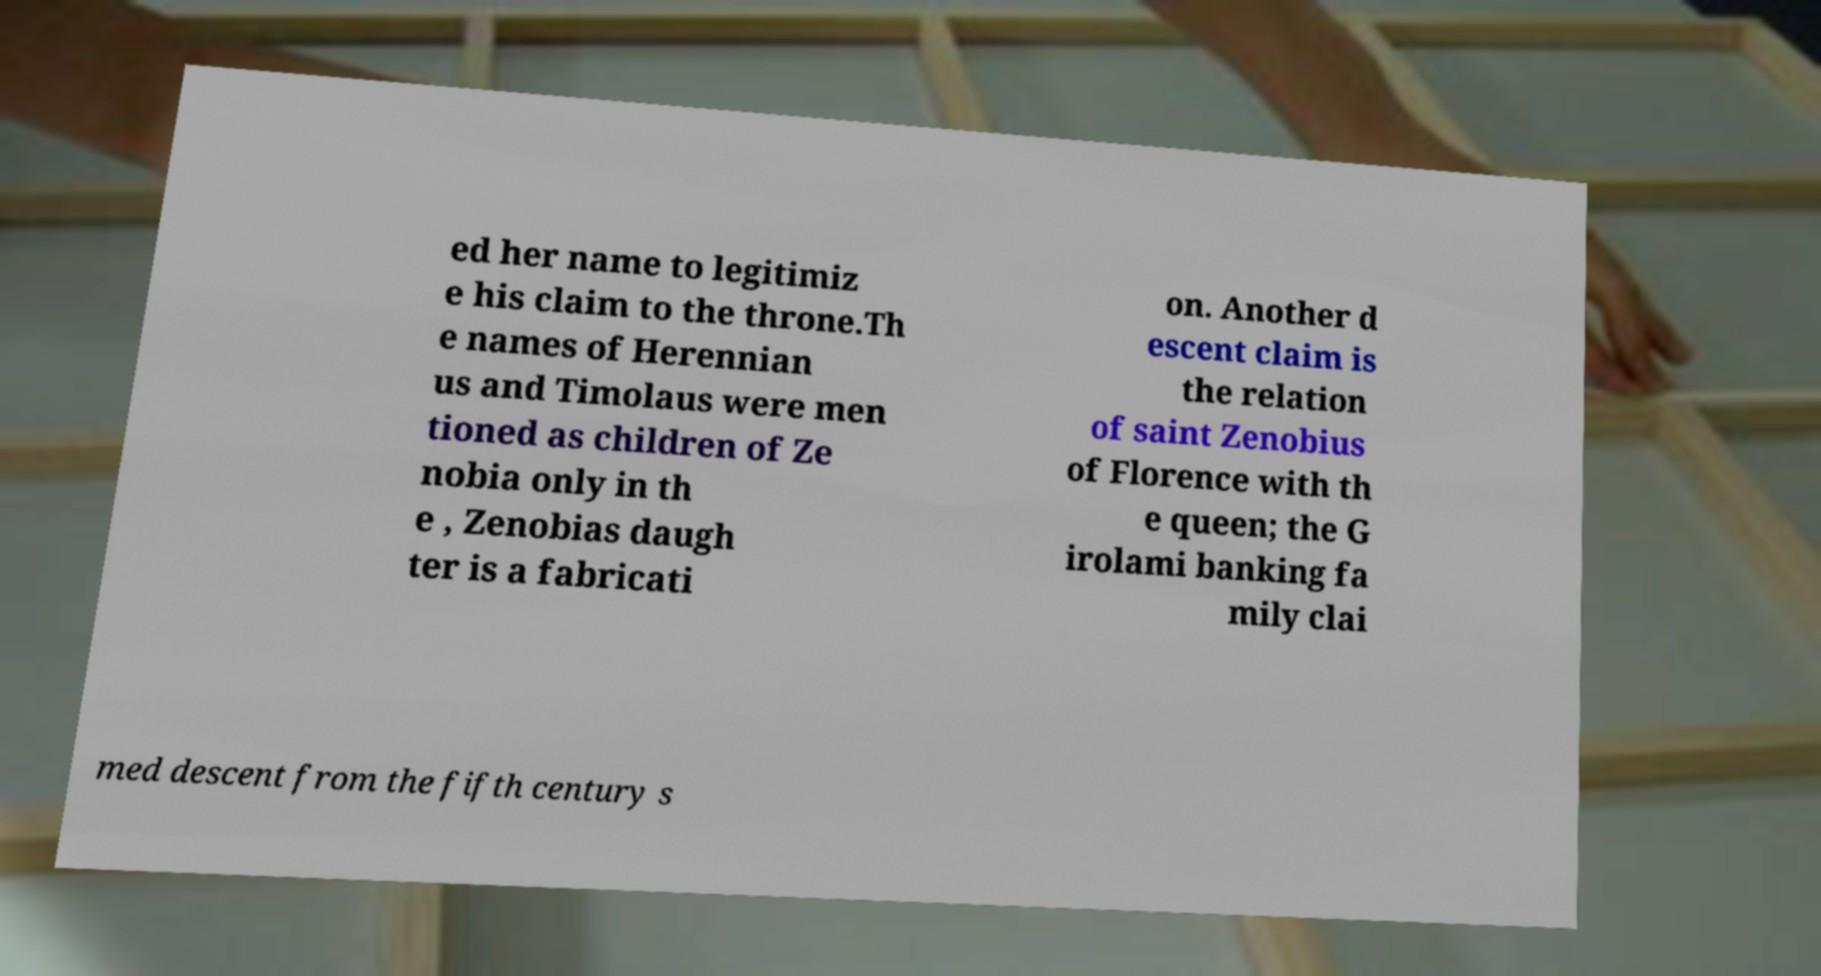Can you accurately transcribe the text from the provided image for me? ed her name to legitimiz e his claim to the throne.Th e names of Herennian us and Timolaus were men tioned as children of Ze nobia only in th e , Zenobias daugh ter is a fabricati on. Another d escent claim is the relation of saint Zenobius of Florence with th e queen; the G irolami banking fa mily clai med descent from the fifth century s 